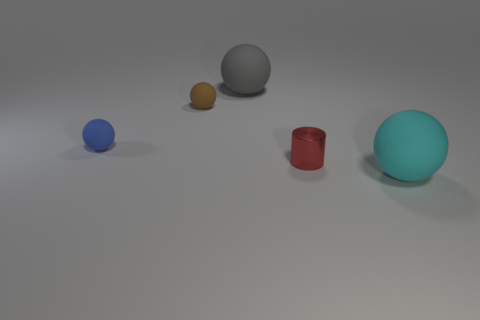What size is the ball that is right of the small thing that is to the right of the big ball that is behind the large cyan sphere?
Provide a short and direct response. Large. Is the number of gray spheres less than the number of large matte balls?
Give a very brief answer. Yes. There is a tiny matte sphere that is on the right side of the rubber thing that is left of the small brown matte object; are there any cyan matte spheres that are to the right of it?
Provide a succinct answer. Yes. There is a big thing that is in front of the small cylinder; does it have the same shape as the gray thing?
Keep it short and to the point. Yes. Is the number of red cylinders behind the cyan matte sphere greater than the number of big yellow cylinders?
Provide a succinct answer. Yes. Is there anything else that has the same color as the metallic cylinder?
Give a very brief answer. No. What color is the large ball that is in front of the large thing that is to the left of the large thing in front of the gray object?
Give a very brief answer. Cyan. Does the red metal cylinder have the same size as the brown matte thing?
Provide a succinct answer. Yes. How many other objects are the same size as the brown matte thing?
Ensure brevity in your answer.  2. Are the sphere that is on the right side of the red shiny cylinder and the blue object behind the cylinder made of the same material?
Make the answer very short. Yes. 